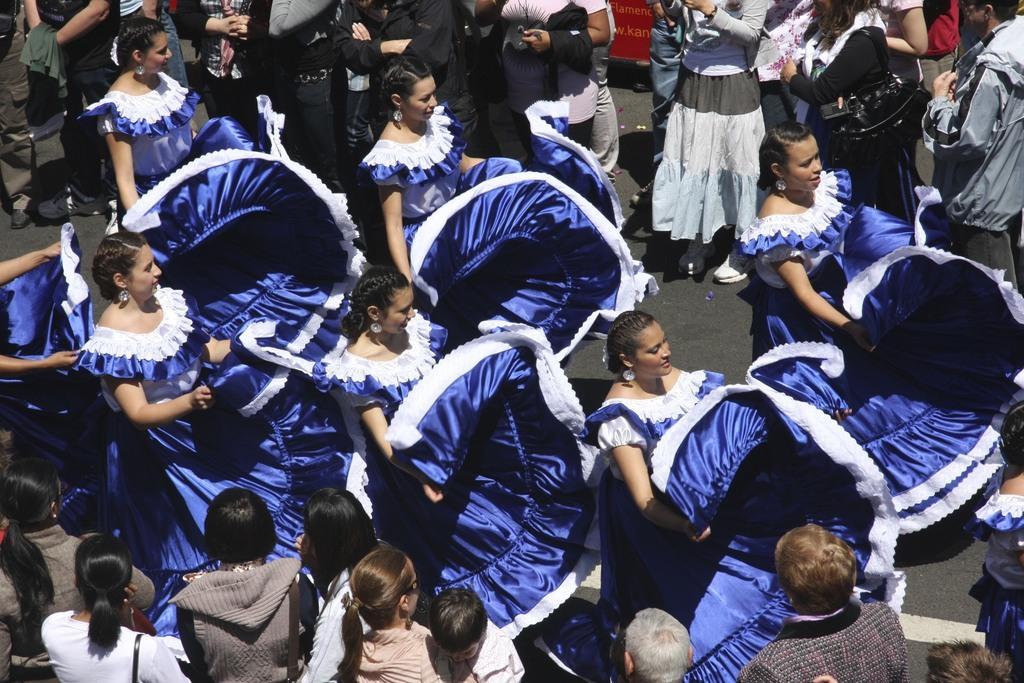Please provide a concise description of this image. In this image we can see people wearing costumes. In the background there is a board. 